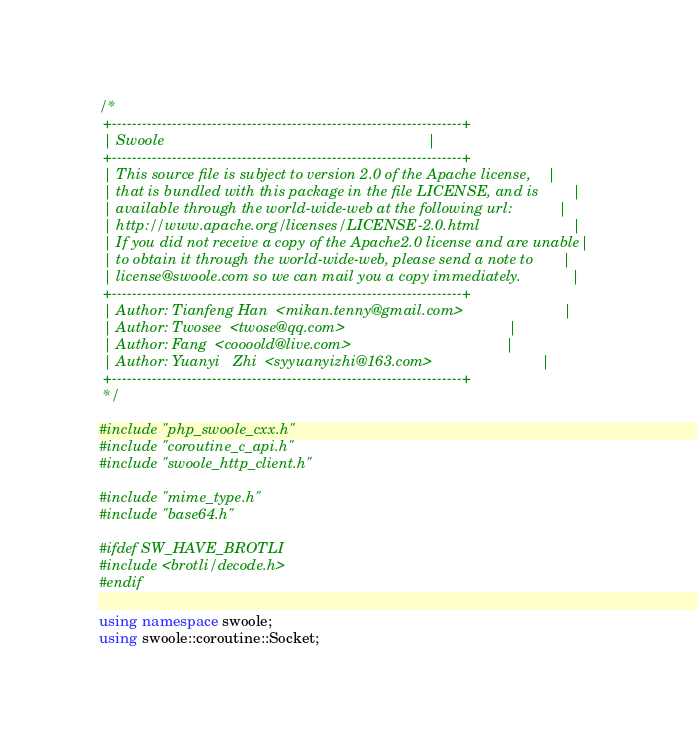Convert code to text. <code><loc_0><loc_0><loc_500><loc_500><_C++_>/*
 +----------------------------------------------------------------------+
 | Swoole                                                               |
 +----------------------------------------------------------------------+
 | This source file is subject to version 2.0 of the Apache license,    |
 | that is bundled with this package in the file LICENSE, and is        |
 | available through the world-wide-web at the following url:           |
 | http://www.apache.org/licenses/LICENSE-2.0.html                      |
 | If you did not receive a copy of the Apache2.0 license and are unable|
 | to obtain it through the world-wide-web, please send a note to       |
 | license@swoole.com so we can mail you a copy immediately.            |
 +----------------------------------------------------------------------+
 | Author: Tianfeng Han  <mikan.tenny@gmail.com>                        |
 | Author: Twosee  <twose@qq.com>                                       |
 | Author: Fang  <coooold@live.com>                                     |
 | Author: Yuanyi   Zhi  <syyuanyizhi@163.com>                          |
 +----------------------------------------------------------------------+
 */

#include "php_swoole_cxx.h"
#include "coroutine_c_api.h"
#include "swoole_http_client.h"

#include "mime_type.h"
#include "base64.h"

#ifdef SW_HAVE_BROTLI
#include <brotli/decode.h>
#endif

using namespace swoole;
using swoole::coroutine::Socket;
</code> 